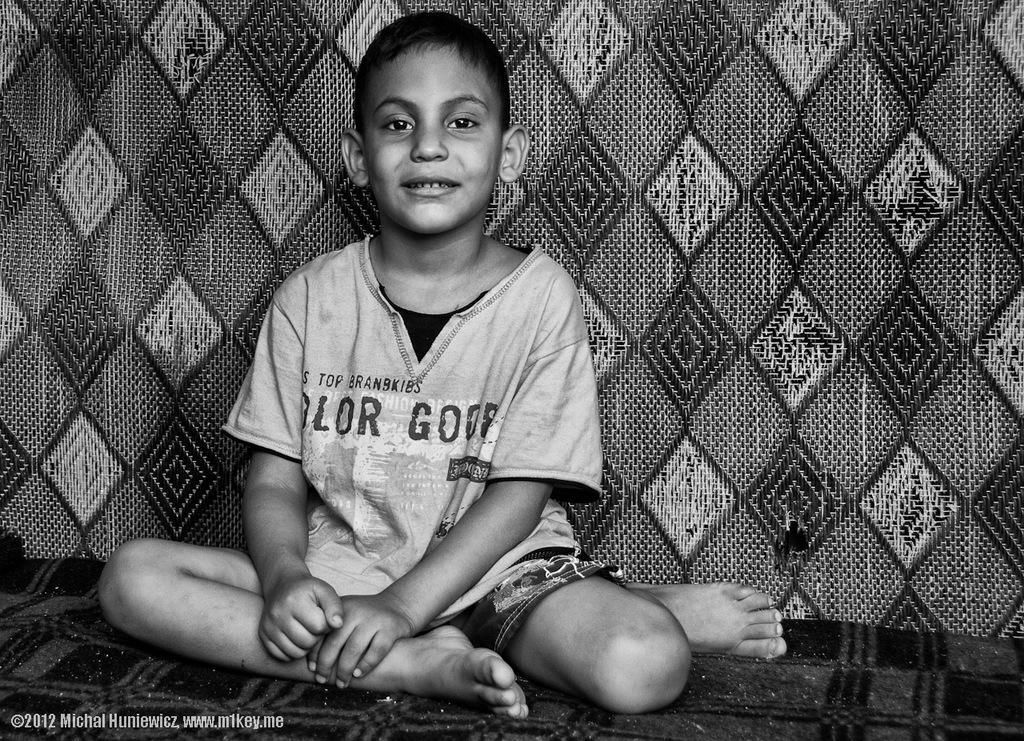Please provide a concise description of this image. Here in this picture we can see a child sitting on a bed over there and he is smiling and behind him we can see a blanket present over there. 